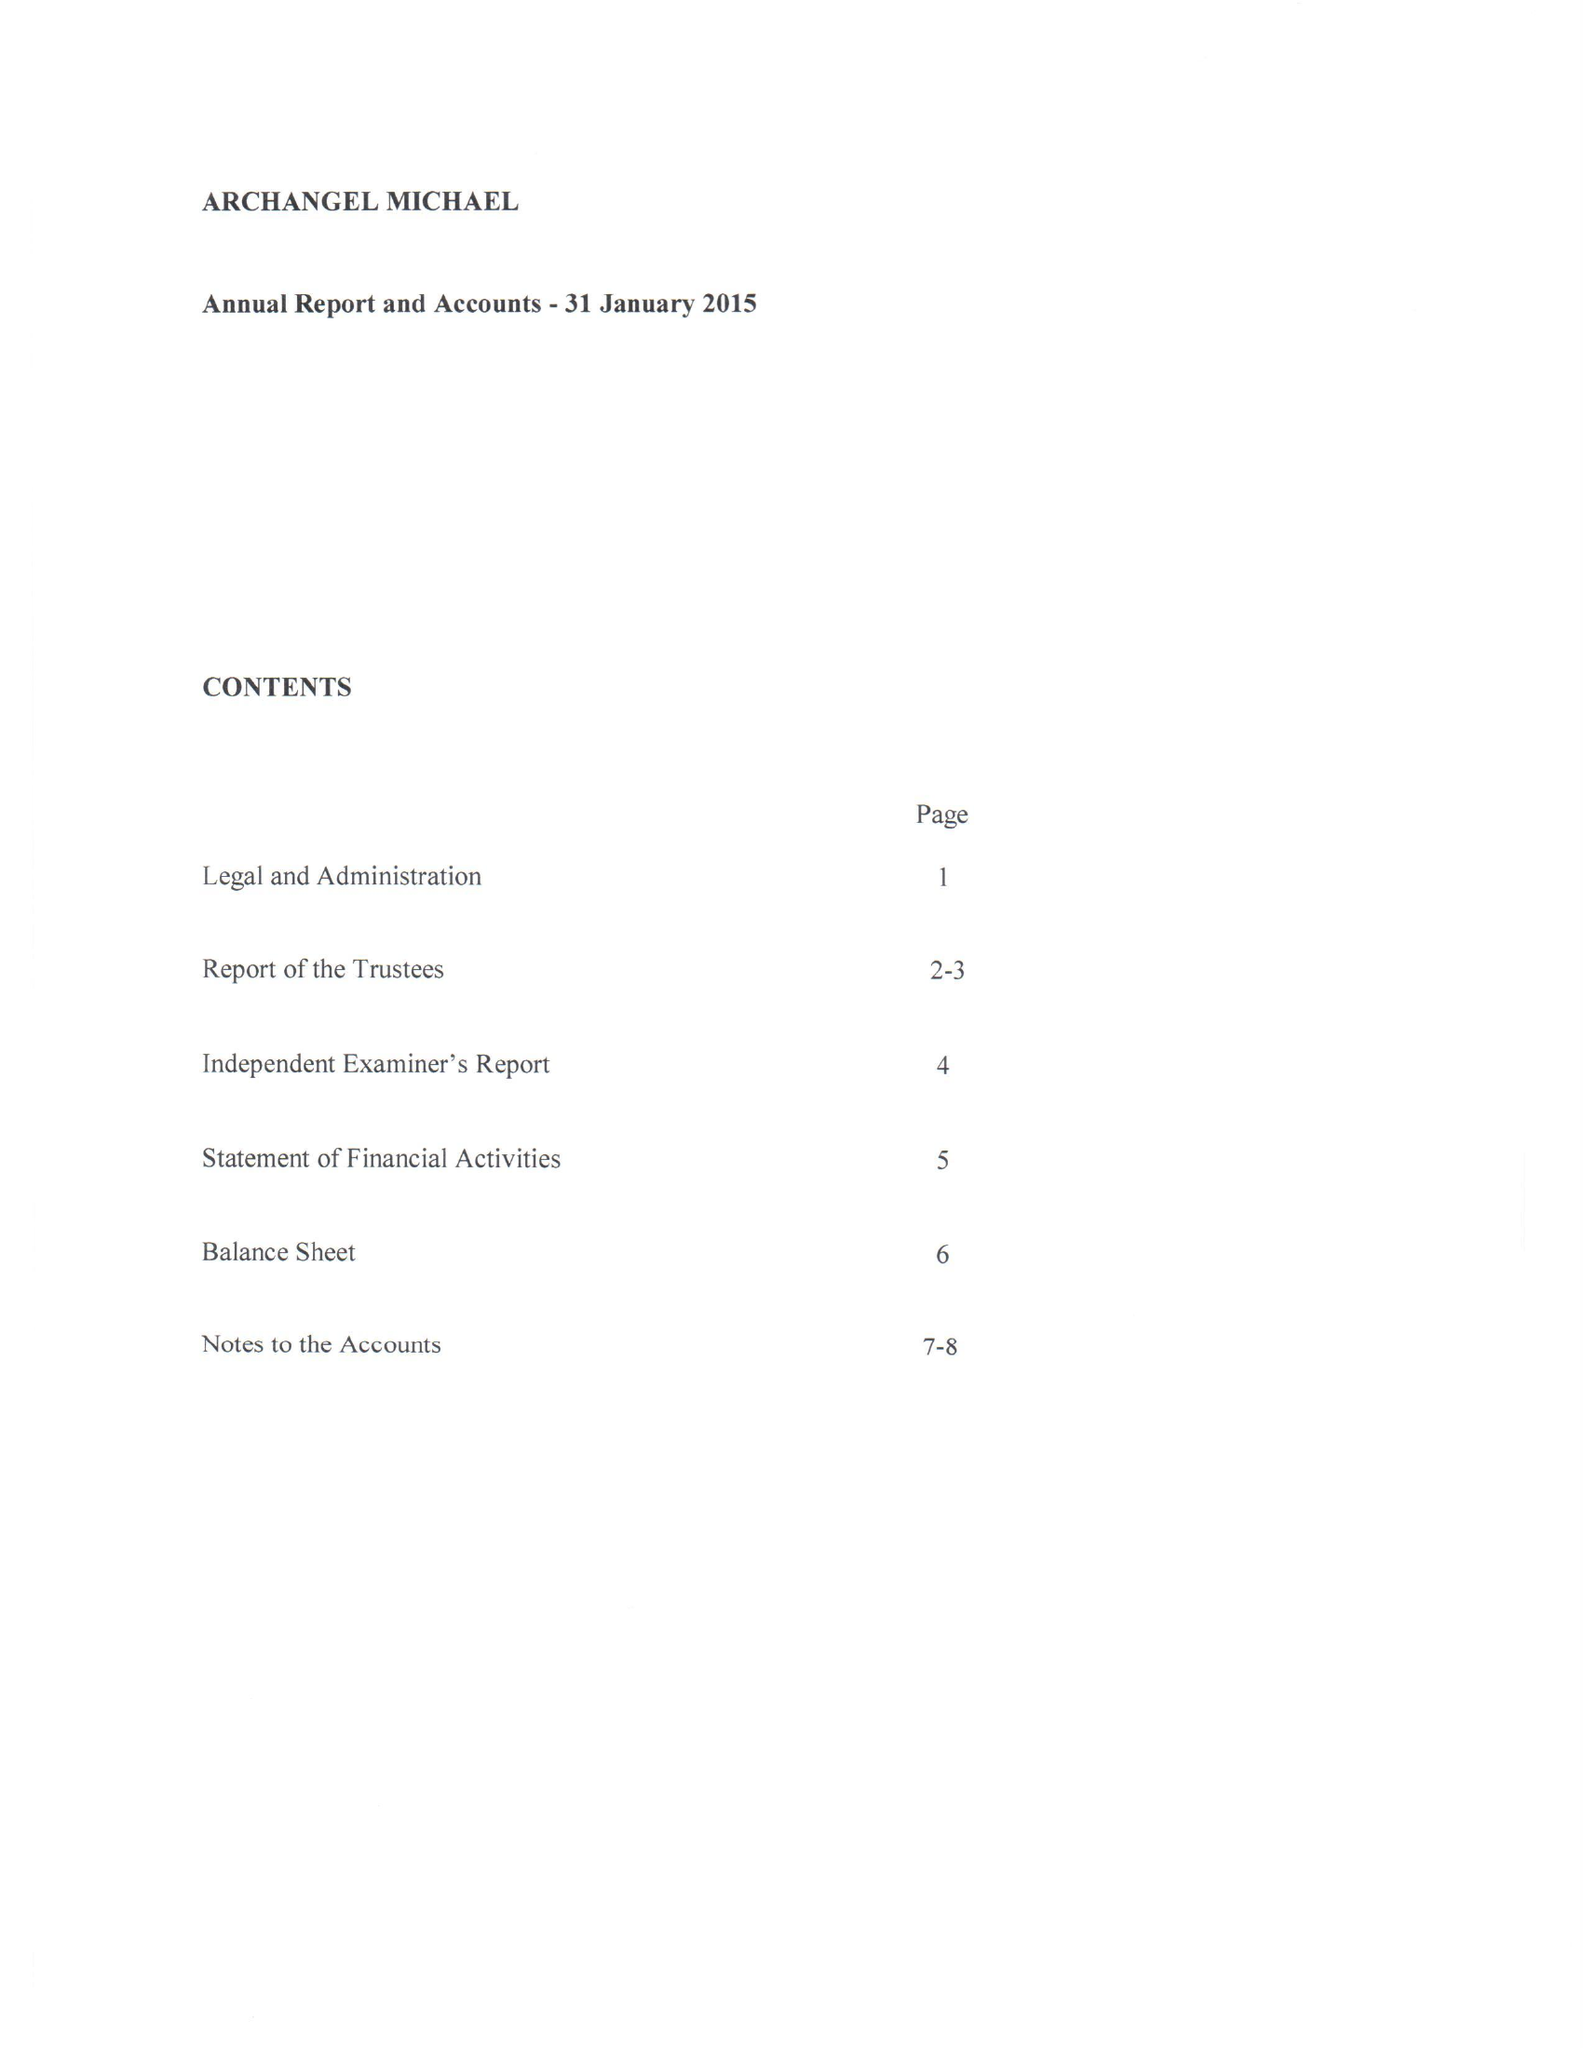What is the value for the address__postcode?
Answer the question using a single word or phrase. SW11 6HT 